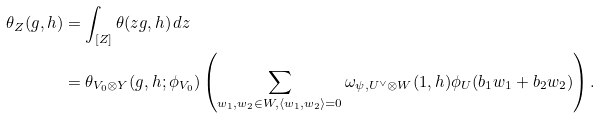<formula> <loc_0><loc_0><loc_500><loc_500>\theta _ { Z } ( g , h ) & = \int _ { [ Z ] } { \theta ( z g , h ) \, d z } \\ & = \theta _ { V _ { 0 } \otimes Y } ( g , h ; \phi _ { V _ { 0 } } ) \left ( \sum _ { w _ { 1 } , w _ { 2 } \in W , \langle w _ { 1 } , w _ { 2 } \rangle = 0 } { \omega _ { \psi , U ^ { \vee } \otimes W } ( 1 , h ) \phi _ { U } ( b _ { 1 } w _ { 1 } + b _ { 2 } w _ { 2 } ) } \right ) .</formula> 